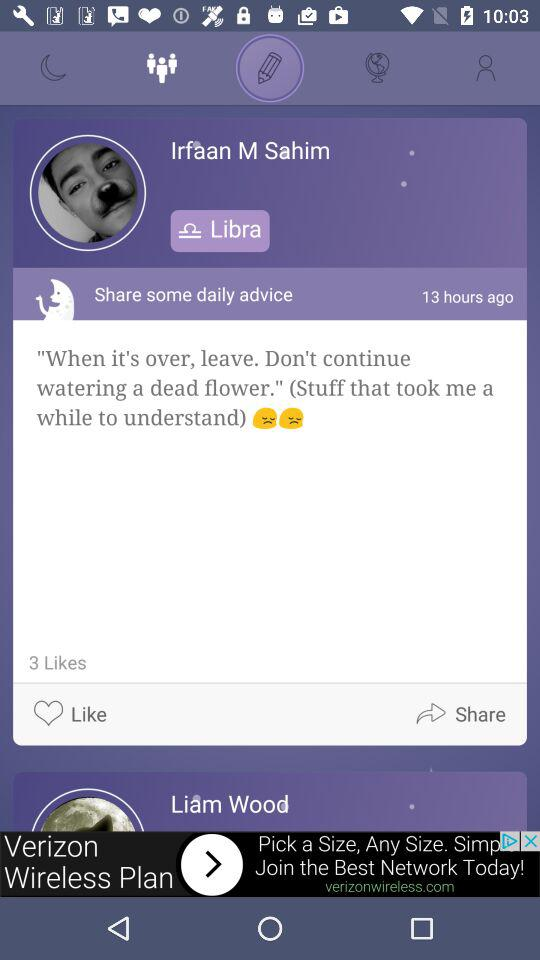How many likes in total did the post get? The post got 3 likes. 